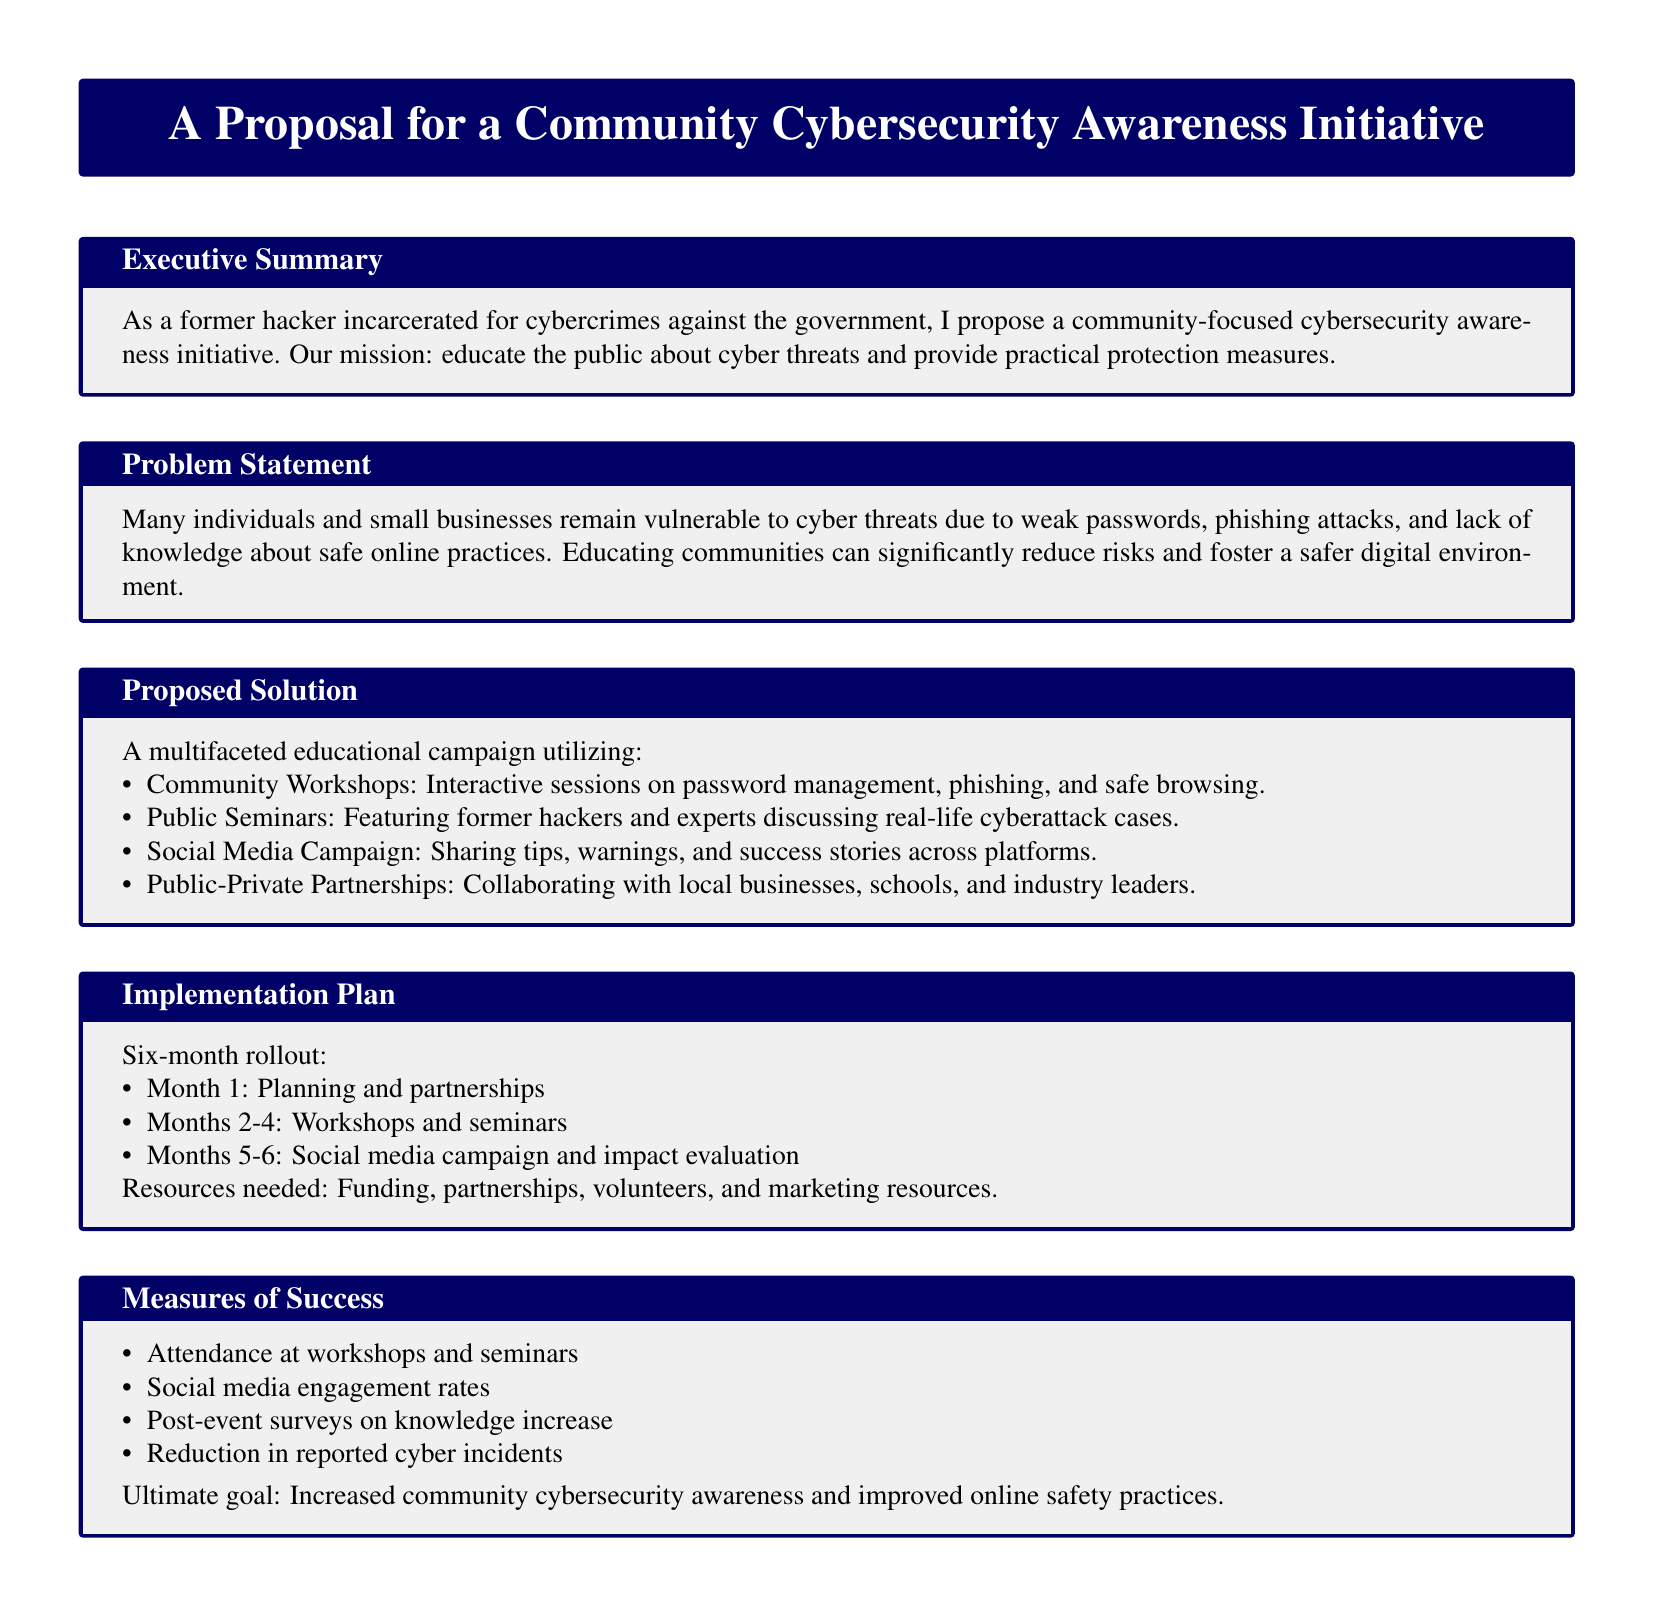what is the title of the proposal? The title of the proposal is found at the top of the document enclosed in a box.
Answer: A Proposal for a Community Cybersecurity Awareness Initiative who is the target audience for the initiative? The target audience is implied in the executive summary and problem statement where public and small businesses are mentioned.
Answer: Public and small businesses what are the methods of the proposed solution? The document lists methods of the proposed solution in a bullet point format.
Answer: Community Workshops, Public Seminars, Social Media Campaign, Public-Private Partnerships how long is the proposed implementation plan? The duration of the implementation plan is specified in the implementation plan section.
Answer: Six months which month focuses on planning and partnerships? The month associated with planning and partnerships is stated in the implementation plan timeline.
Answer: Month 1 what is the ultimate goal of the initiative? The ultimate goal is explicitly stated in the measures of success section of the document.
Answer: Increased community cybersecurity awareness and improved online safety practices how will success be measured? Success measurement methods are listed in the measures of success section.
Answer: Attendance at workshops and seminars, Social media engagement rates, Post-event surveys on knowledge increase, Reduction in reported cyber incidents who will lead public seminars? The public seminars will be led by individuals with specific backgrounds mentioned in the proposed solution.
Answer: Former hackers and experts 